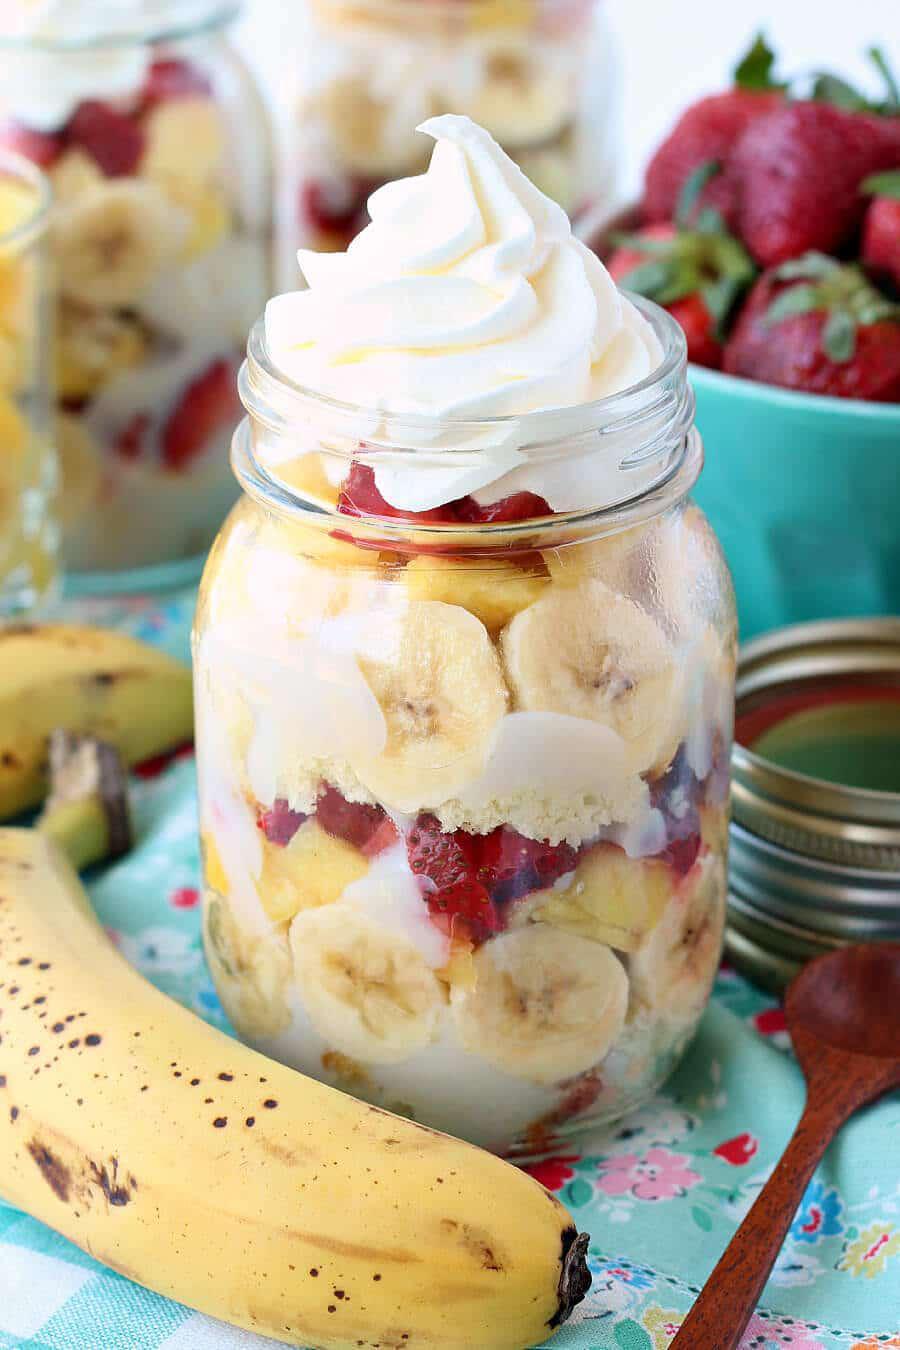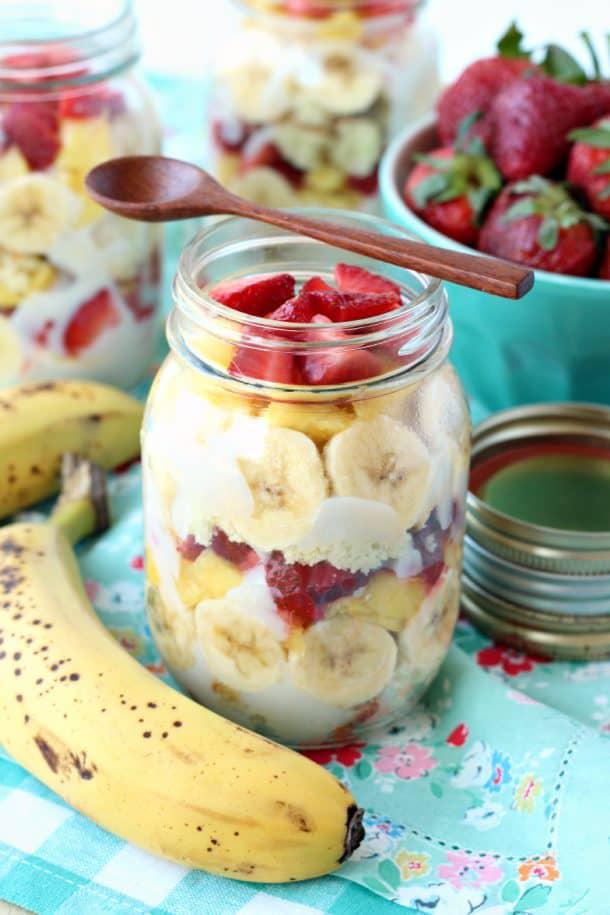The first image is the image on the left, the second image is the image on the right. Given the left and right images, does the statement "An image shows a whipped cream-topped dessert in a jar next to unpeeled bananas." hold true? Answer yes or no. Yes. The first image is the image on the left, the second image is the image on the right. Considering the images on both sides, is "A banana is shown near at least one of the desserts." valid? Answer yes or no. Yes. 